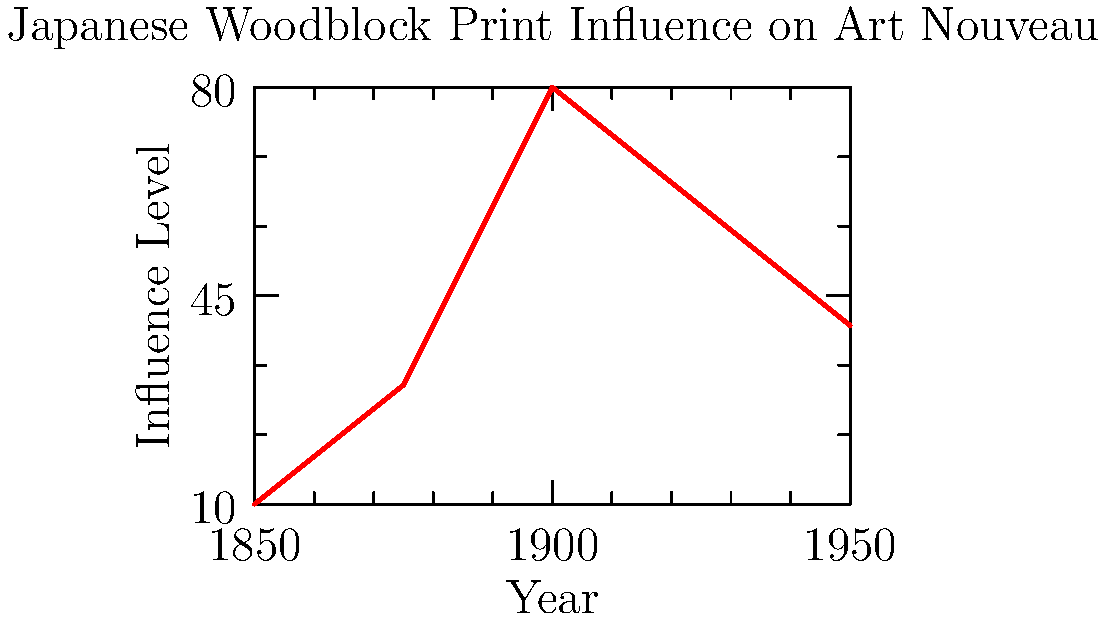Based on the graph showing the influence of Japanese woodblock print techniques on Art Nouveau poster designs over time, in which year did this influence reach its peak? To determine the year when the influence of Japanese woodblock print techniques on Art Nouveau poster designs reached its peak, we need to follow these steps:

1. Examine the graph, which shows the influence level over time from 1850 to 1950.
2. Look for the highest point on the curve, which represents the maximum influence.
3. The curve rises sharply from 1875 to 1900.
4. The peak of the curve occurs at the year 1900.
5. After 1900, the influence starts to decline.

Therefore, the influence of Japanese woodblock print techniques on Art Nouveau poster designs reached its peak in 1900.
Answer: 1900 